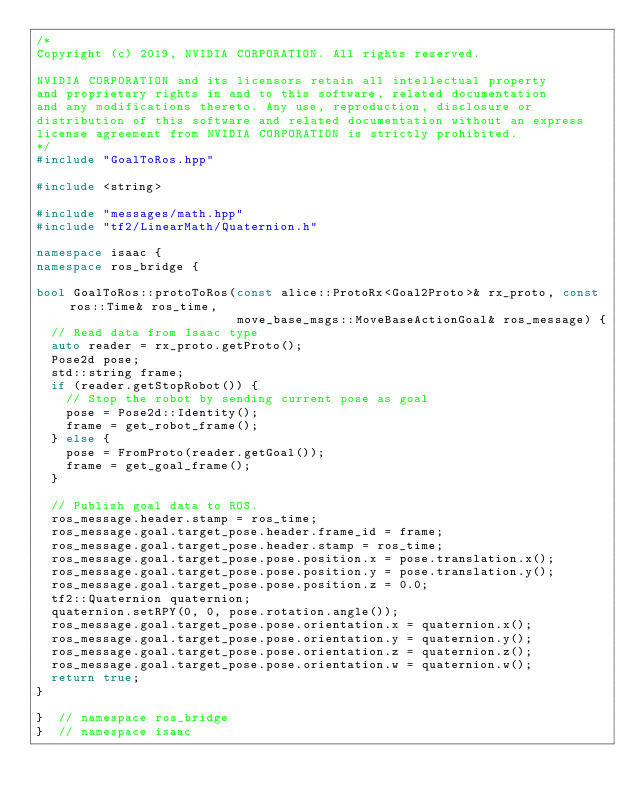Convert code to text. <code><loc_0><loc_0><loc_500><loc_500><_C++_>/*
Copyright (c) 2019, NVIDIA CORPORATION. All rights reserved.

NVIDIA CORPORATION and its licensors retain all intellectual property
and proprietary rights in and to this software, related documentation
and any modifications thereto. Any use, reproduction, disclosure or
distribution of this software and related documentation without an express
license agreement from NVIDIA CORPORATION is strictly prohibited.
*/
#include "GoalToRos.hpp"

#include <string>

#include "messages/math.hpp"
#include "tf2/LinearMath/Quaternion.h"

namespace isaac {
namespace ros_bridge {

bool GoalToRos::protoToRos(const alice::ProtoRx<Goal2Proto>& rx_proto, const ros::Time& ros_time,
                           move_base_msgs::MoveBaseActionGoal& ros_message) {
  // Read data from Isaac type
  auto reader = rx_proto.getProto();
  Pose2d pose;
  std::string frame;
  if (reader.getStopRobot()) {
    // Stop the robot by sending current pose as goal
    pose = Pose2d::Identity();
    frame = get_robot_frame();
  } else {
    pose = FromProto(reader.getGoal());
    frame = get_goal_frame();
  }

  // Publish goal data to ROS.
  ros_message.header.stamp = ros_time;
  ros_message.goal.target_pose.header.frame_id = frame;
  ros_message.goal.target_pose.header.stamp = ros_time;
  ros_message.goal.target_pose.pose.position.x = pose.translation.x();
  ros_message.goal.target_pose.pose.position.y = pose.translation.y();
  ros_message.goal.target_pose.pose.position.z = 0.0;
  tf2::Quaternion quaternion;
  quaternion.setRPY(0, 0, pose.rotation.angle());
  ros_message.goal.target_pose.pose.orientation.x = quaternion.x();
  ros_message.goal.target_pose.pose.orientation.y = quaternion.y();
  ros_message.goal.target_pose.pose.orientation.z = quaternion.z();
  ros_message.goal.target_pose.pose.orientation.w = quaternion.w();
  return true;
}

}  // namespace ros_bridge
}  // namespace isaac
</code> 